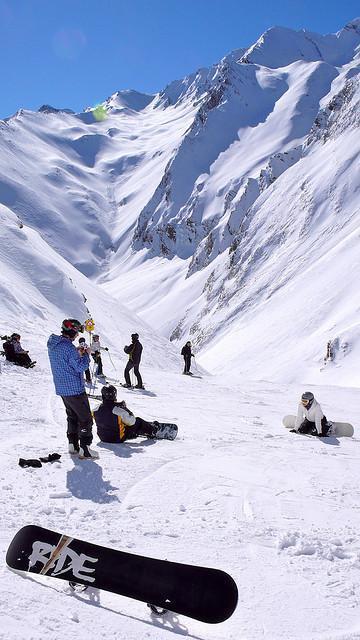How many men are there present?
Give a very brief answer. 8. How many people are in the photo?
Give a very brief answer. 2. 